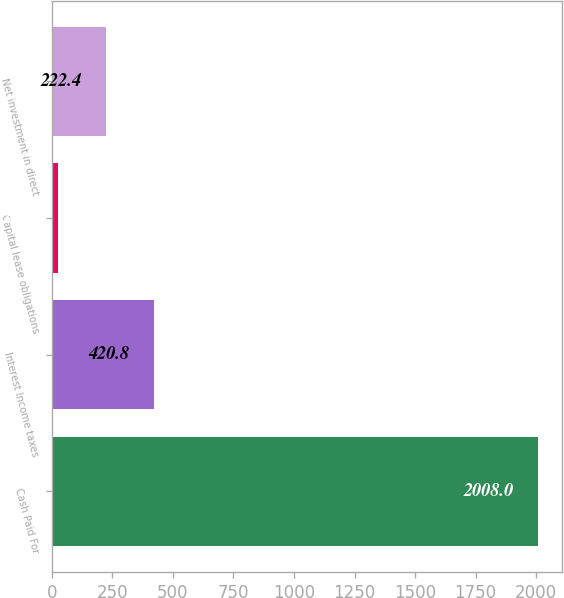Convert chart. <chart><loc_0><loc_0><loc_500><loc_500><bar_chart><fcel>Cash Paid For<fcel>Interest Income taxes<fcel>Capital lease obligations<fcel>Net investment in direct<nl><fcel>2008<fcel>420.8<fcel>24<fcel>222.4<nl></chart> 